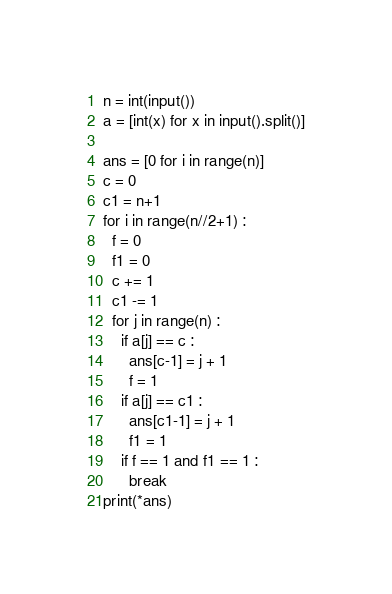Convert code to text. <code><loc_0><loc_0><loc_500><loc_500><_Python_>n = int(input())
a = [int(x) for x in input().split()]

ans = [0 for i in range(n)]
c = 0
c1 = n+1
for i in range(n//2+1) :
  f = 0
  f1 = 0
  c += 1
  c1 -= 1
  for j in range(n) :
    if a[j] == c :
      ans[c-1] = j + 1
      f = 1
    if a[j] == c1 :
      ans[c1-1] = j + 1
      f1 = 1
    if f == 1 and f1 == 1 :
      break
print(*ans)</code> 